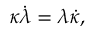Convert formula to latex. <formula><loc_0><loc_0><loc_500><loc_500>\kappa \dot { \lambda } = \lambda \dot { \kappa } ,</formula> 